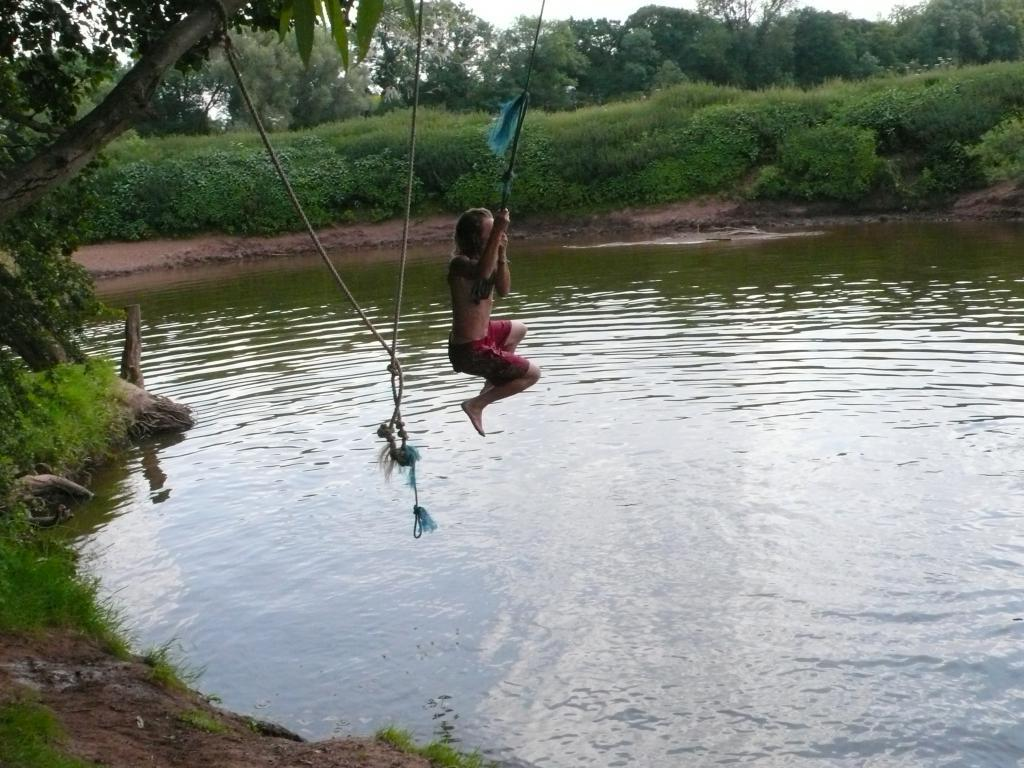What is the person in the image holding? The person in the image is holding a rope. What type of natural environment is depicted in the image? The image features trees, water, plants, and grass, indicating a natural environment. What time of day is it in the image, and are there any fairies present? The time of day cannot be determined from the image, and there are no fairies present. 